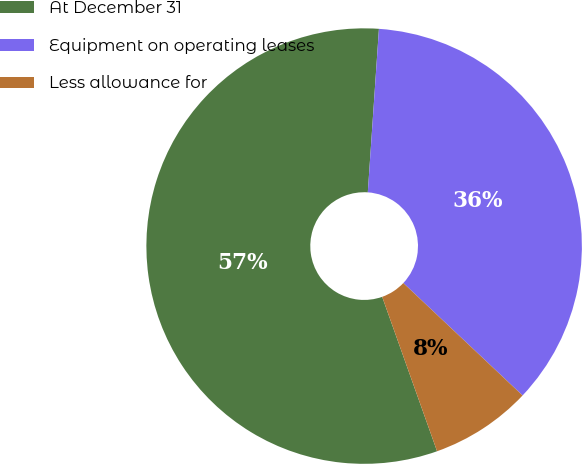Convert chart. <chart><loc_0><loc_0><loc_500><loc_500><pie_chart><fcel>At December 31<fcel>Equipment on operating leases<fcel>Less allowance for<nl><fcel>56.52%<fcel>35.95%<fcel>7.53%<nl></chart> 